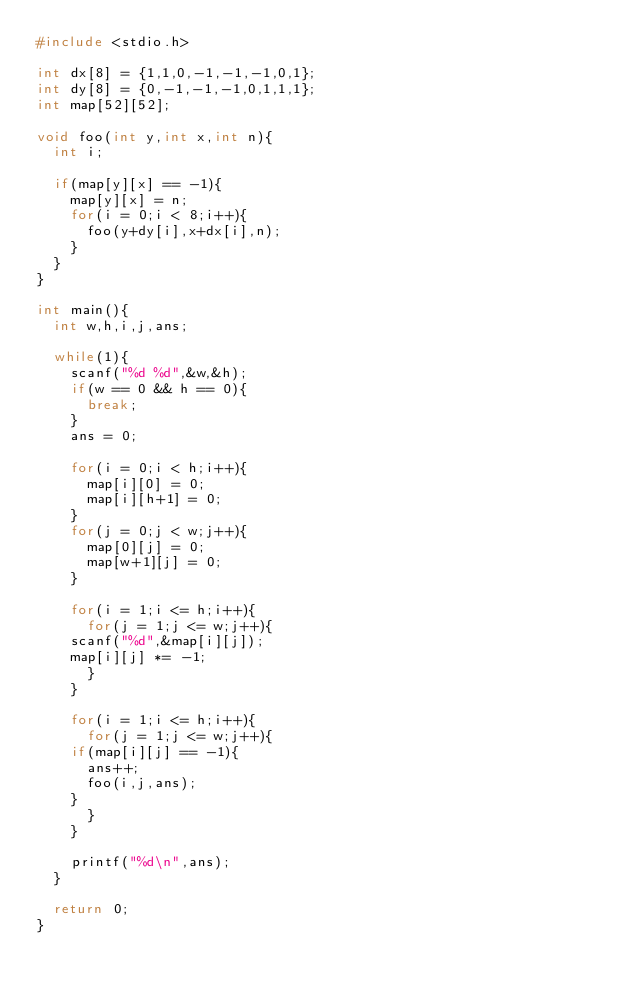<code> <loc_0><loc_0><loc_500><loc_500><_C_>#include <stdio.h>

int dx[8] = {1,1,0,-1,-1,-1,0,1};
int dy[8] = {0,-1,-1,-1,0,1,1,1};
int map[52][52];

void foo(int y,int x,int n){
  int i;

  if(map[y][x] == -1){
    map[y][x] = n;
    for(i = 0;i < 8;i++){
      foo(y+dy[i],x+dx[i],n);
    }
  }
}

int main(){
  int w,h,i,j,ans;

  while(1){
    scanf("%d %d",&w,&h);
    if(w == 0 && h == 0){
      break;
    }
    ans = 0;

    for(i = 0;i < h;i++){
      map[i][0] = 0;
      map[i][h+1] = 0;
    }
    for(j = 0;j < w;j++){
      map[0][j] = 0;
      map[w+1][j] = 0;
    }

    for(i = 1;i <= h;i++){
      for(j = 1;j <= w;j++){
	scanf("%d",&map[i][j]);
	map[i][j] *= -1;
      }
    }

    for(i = 1;i <= h;i++){
      for(j = 1;j <= w;j++){
	if(map[i][j] == -1){
	  ans++;
	  foo(i,j,ans);
	}
      }
    }

    printf("%d\n",ans);
  }

  return 0;
}</code> 